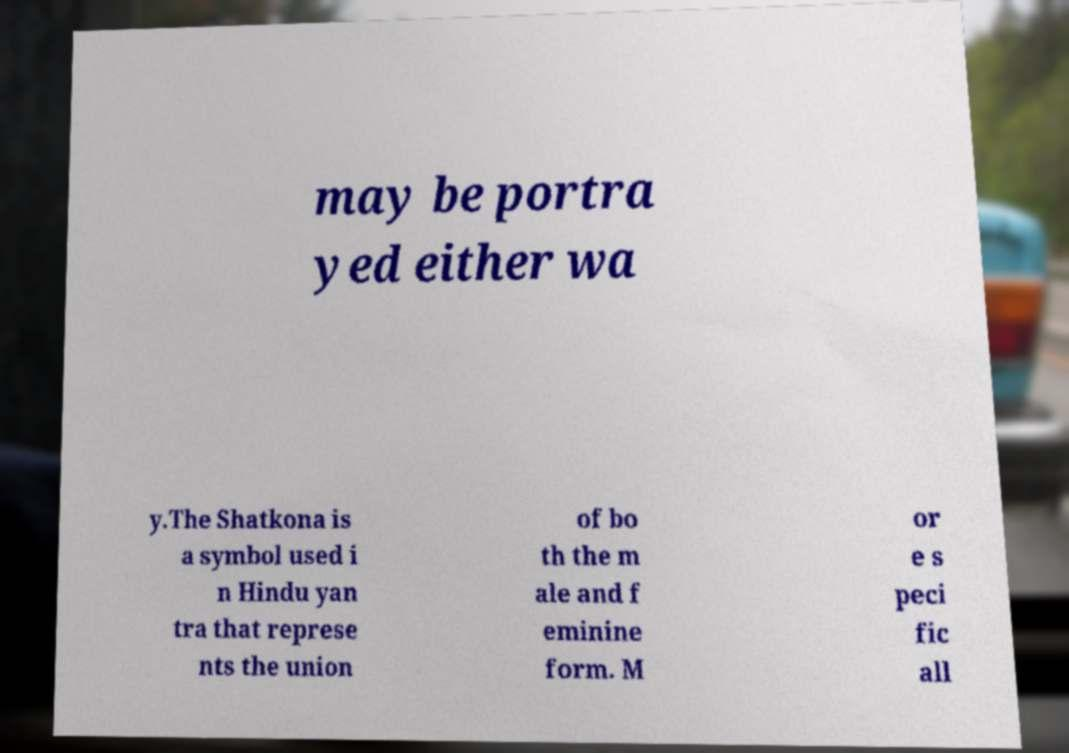There's text embedded in this image that I need extracted. Can you transcribe it verbatim? may be portra yed either wa y.The Shatkona is a symbol used i n Hindu yan tra that represe nts the union of bo th the m ale and f eminine form. M or e s peci fic all 